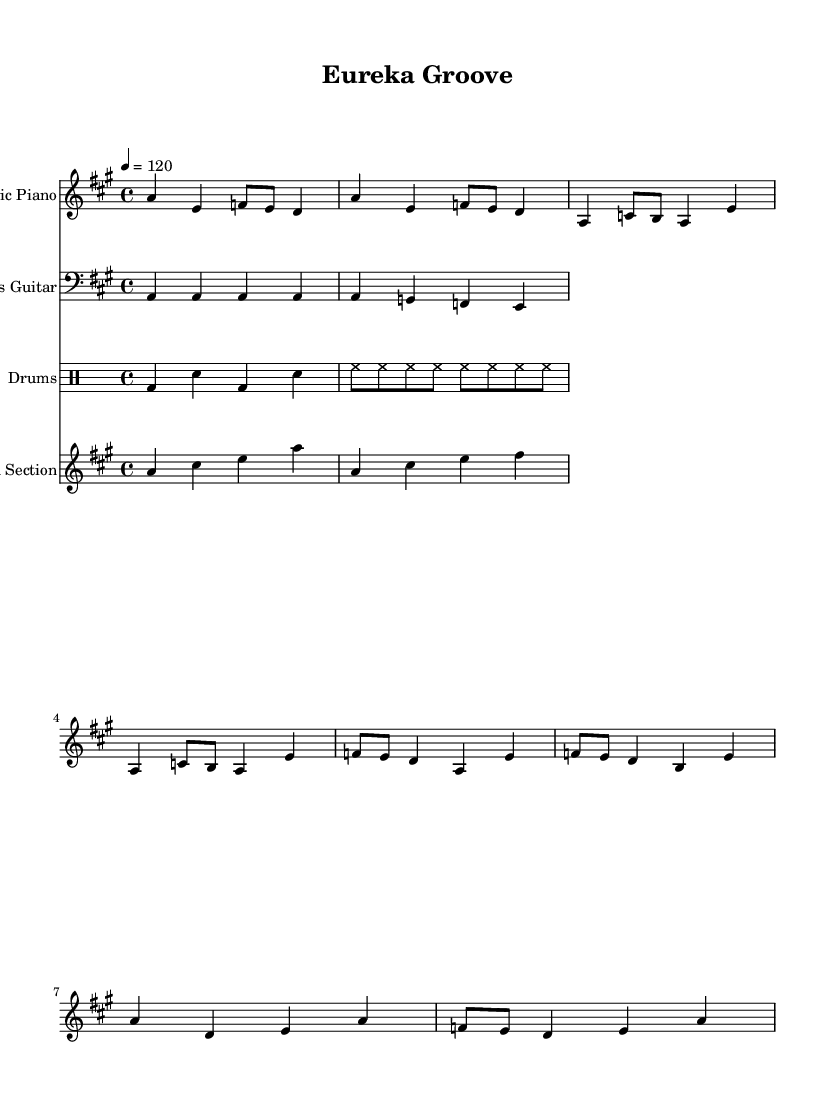What is the key signature of this music? The key signature indicates that the piece is in A major, which consists of three sharps (F#, C#, and G#). You can identify the key signature at the beginning of the staff, just after the clef sign.
Answer: A major What is the time signature of this music? The time signature is displayed at the beginning of the piece and shows four beats per measure, which is represented as 4/4. This indicates a common time signature for disco music, allowing for a steady, upbeat feel.
Answer: 4/4 What is the tempo of this music? The tempo is indicated by the marking "4 = 120", which means that there are 120 beats per minute. This is a fast tempo, typical for disco tracks to keep the dance vibe energetic.
Answer: 120 How many measures are in the chorus section? Observing the sheet music, the chorus section is distinct and consists of four measures, marked by the rhythmic pattern and transition from the pre-chorus to the chorus. Counting them confirms this.
Answer: 4 What is the primary instrument used in this piece? The primary instrument is the electric piano, which is indicated in the staff name. It plays the main melody throughout the piece, showcasing its prominence in disco music arrangements.
Answer: Electric Piano How does the bass pattern contribute to the disco feel? The bass pattern, characterized by the steady repeated A notes followed by a descending bass line in a rhythmic sequence, helps establish a solid groove that is foundational for disco music. This repetitive rhythmic structure enhances danceability, which is a central element of disco tracks.
Answer: Groove foundation What are the lyrical themes reflected in the lyrics? The lyrics prominently express themes of creativity and discovery, marked by phrases like “ideas start to flow” and “Eureka! I've found it”, capturing the joyous and uplifting sentiment associated with creative breakthroughs.
Answer: Creativity and discovery 